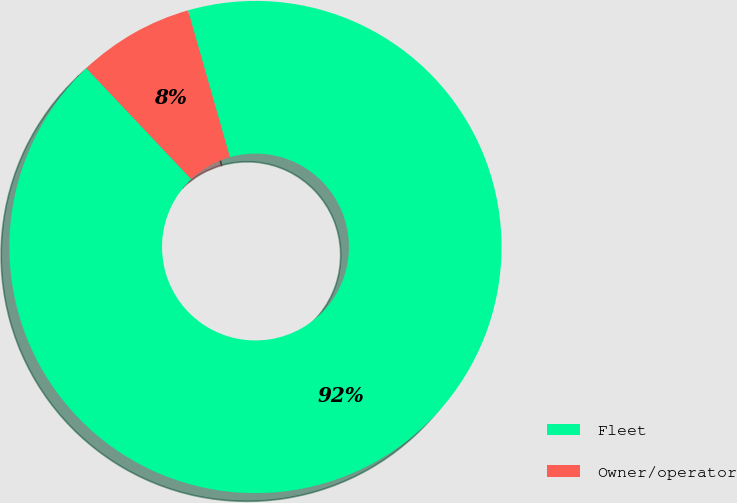Convert chart. <chart><loc_0><loc_0><loc_500><loc_500><pie_chart><fcel>Fleet<fcel>Owner/operator<nl><fcel>92.37%<fcel>7.63%<nl></chart> 